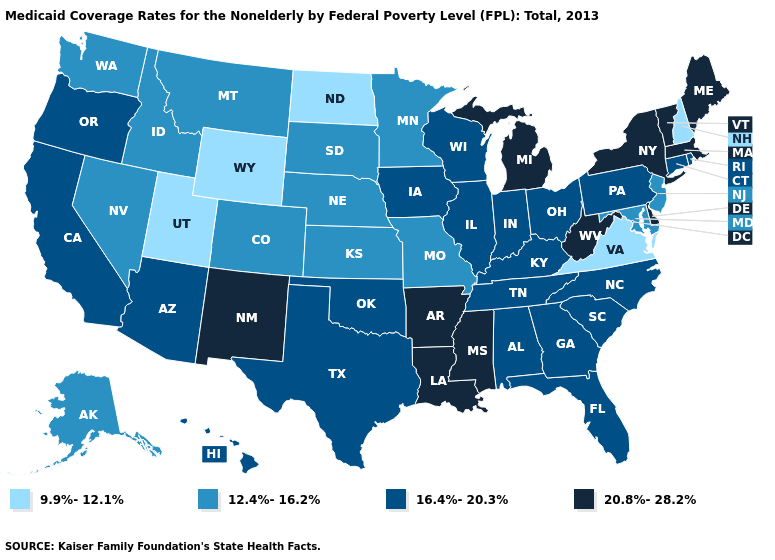Does Oregon have a higher value than Virginia?
Keep it brief. Yes. What is the lowest value in the USA?
Be succinct. 9.9%-12.1%. What is the highest value in the MidWest ?
Short answer required. 20.8%-28.2%. Does Montana have the lowest value in the USA?
Be succinct. No. Name the states that have a value in the range 9.9%-12.1%?
Answer briefly. New Hampshire, North Dakota, Utah, Virginia, Wyoming. What is the value of California?
Short answer required. 16.4%-20.3%. Name the states that have a value in the range 9.9%-12.1%?
Answer briefly. New Hampshire, North Dakota, Utah, Virginia, Wyoming. What is the value of Colorado?
Write a very short answer. 12.4%-16.2%. Name the states that have a value in the range 9.9%-12.1%?
Be succinct. New Hampshire, North Dakota, Utah, Virginia, Wyoming. Does Arizona have a lower value than Mississippi?
Concise answer only. Yes. Does Iowa have the same value as Alaska?
Concise answer only. No. What is the value of Utah?
Concise answer only. 9.9%-12.1%. Name the states that have a value in the range 20.8%-28.2%?
Keep it brief. Arkansas, Delaware, Louisiana, Maine, Massachusetts, Michigan, Mississippi, New Mexico, New York, Vermont, West Virginia. Does Arkansas have a higher value than Louisiana?
Write a very short answer. No. 